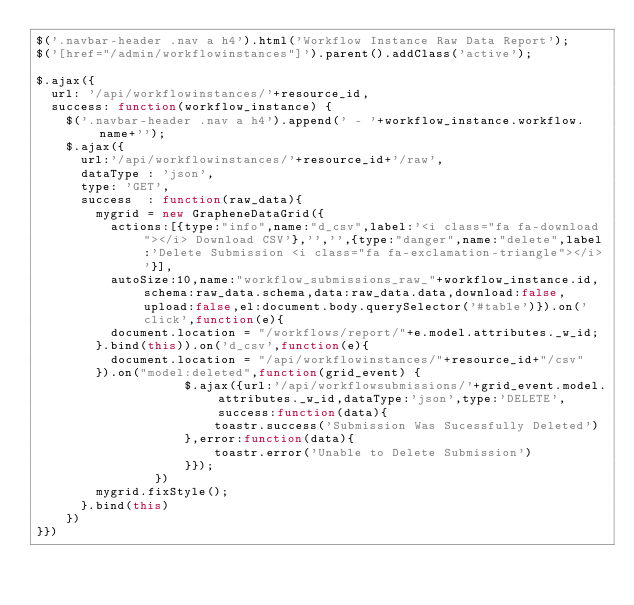Convert code to text. <code><loc_0><loc_0><loc_500><loc_500><_JavaScript_>$('.navbar-header .nav a h4').html('Workflow Instance Raw Data Report');
$('[href="/admin/workflowinstances"]').parent().addClass('active');

$.ajax({
	url: '/api/workflowinstances/'+resource_id,
	success: function(workflow_instance) {
		$('.navbar-header .nav a h4').append(' - '+workflow_instance.workflow.name+'');
		$.ajax({
			url:'/api/workflowinstances/'+resource_id+'/raw',
			dataType : 'json',
			type: 'GET',
			success  : function(raw_data){
				mygrid = new GrapheneDataGrid({
					actions:[{type:"info",name:"d_csv",label:'<i class="fa fa-download"></i> Download CSV'},'','',{type:"danger",name:"delete",label:'Delete Submission <i class="fa fa-exclamation-triangle"></i>'}],
					autoSize:10,name:"workflow_submissions_raw_"+workflow_instance.id,schema:raw_data.schema,data:raw_data.data,download:false,upload:false,el:document.body.querySelector('#table')}).on('click',function(e){
					document.location = "/workflows/report/"+e.model.attributes._w_id;
				}.bind(this)).on('d_csv',function(e){
					document.location = "/api/workflowinstances/"+resource_id+"/csv"
				}).on("model:deleted",function(grid_event) {
                    $.ajax({url:'/api/workflowsubmissions/'+grid_event.model.attributes._w_id,dataType:'json',type:'DELETE',success:function(data){
                        toastr.success('Submission Was Sucessfully Deleted')
                    },error:function(data){
                        toastr.error('Unable to Delete Submission')
                    }});
                })
				mygrid.fixStyle();
			}.bind(this)
		})
}})
</code> 